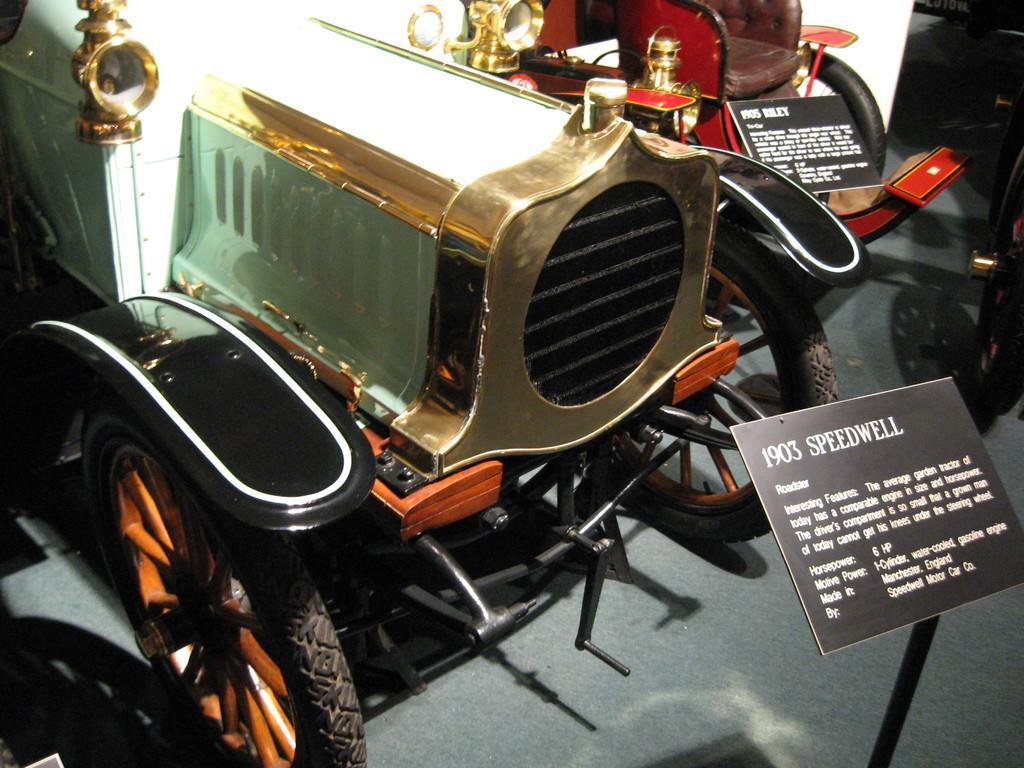Can you describe this image briefly? In this picture I can see there is a car and it has wheels, a metal frame and there is a board here and there is some information written on it. In the backdrop there is a another car and it has a board and some information on it. 